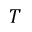Convert formula to latex. <formula><loc_0><loc_0><loc_500><loc_500>T</formula> 